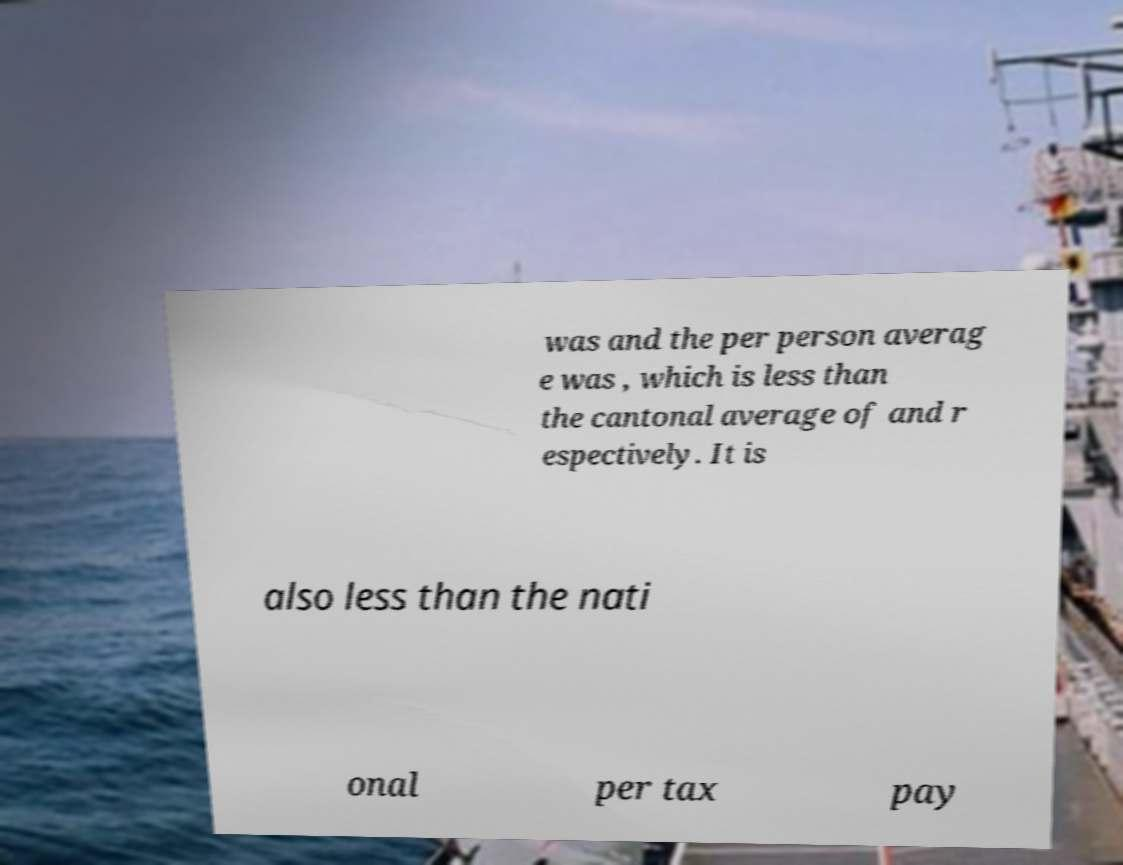Could you extract and type out the text from this image? was and the per person averag e was , which is less than the cantonal average of and r espectively. It is also less than the nati onal per tax pay 